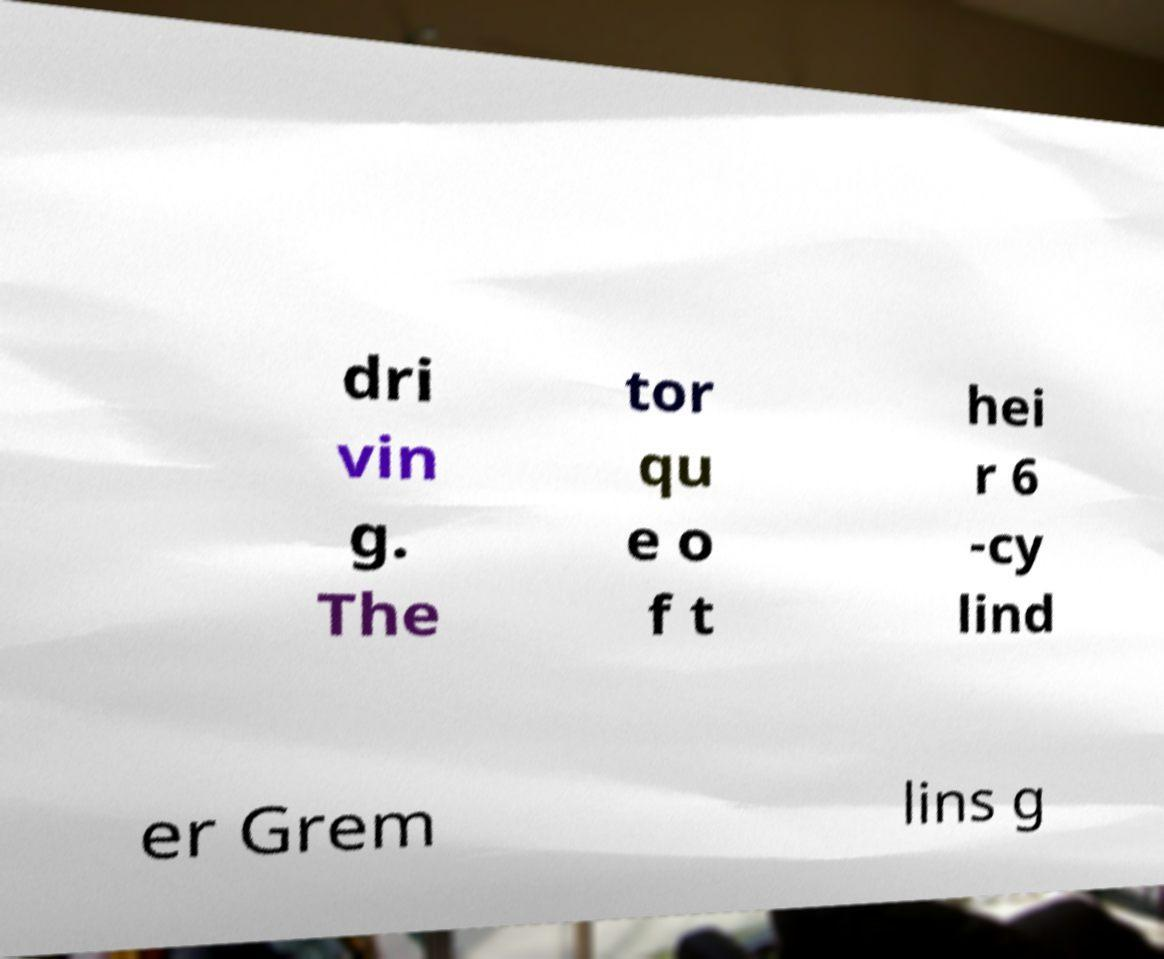For documentation purposes, I need the text within this image transcribed. Could you provide that? dri vin g. The tor qu e o f t hei r 6 -cy lind er Grem lins g 